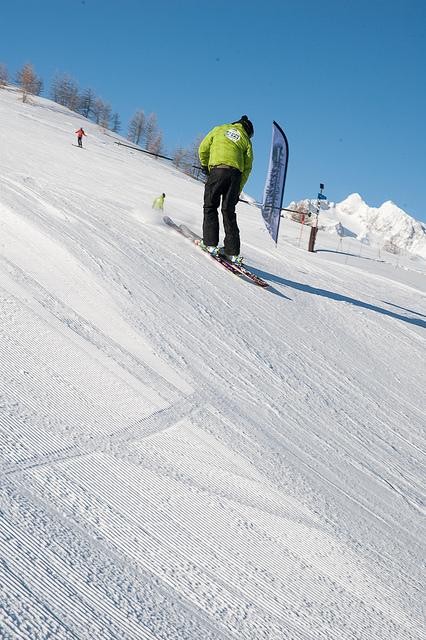What is the color of the snow?
Keep it brief. White. How many people are skiing?
Give a very brief answer. 2. Is it winter?
Answer briefly. Yes. 